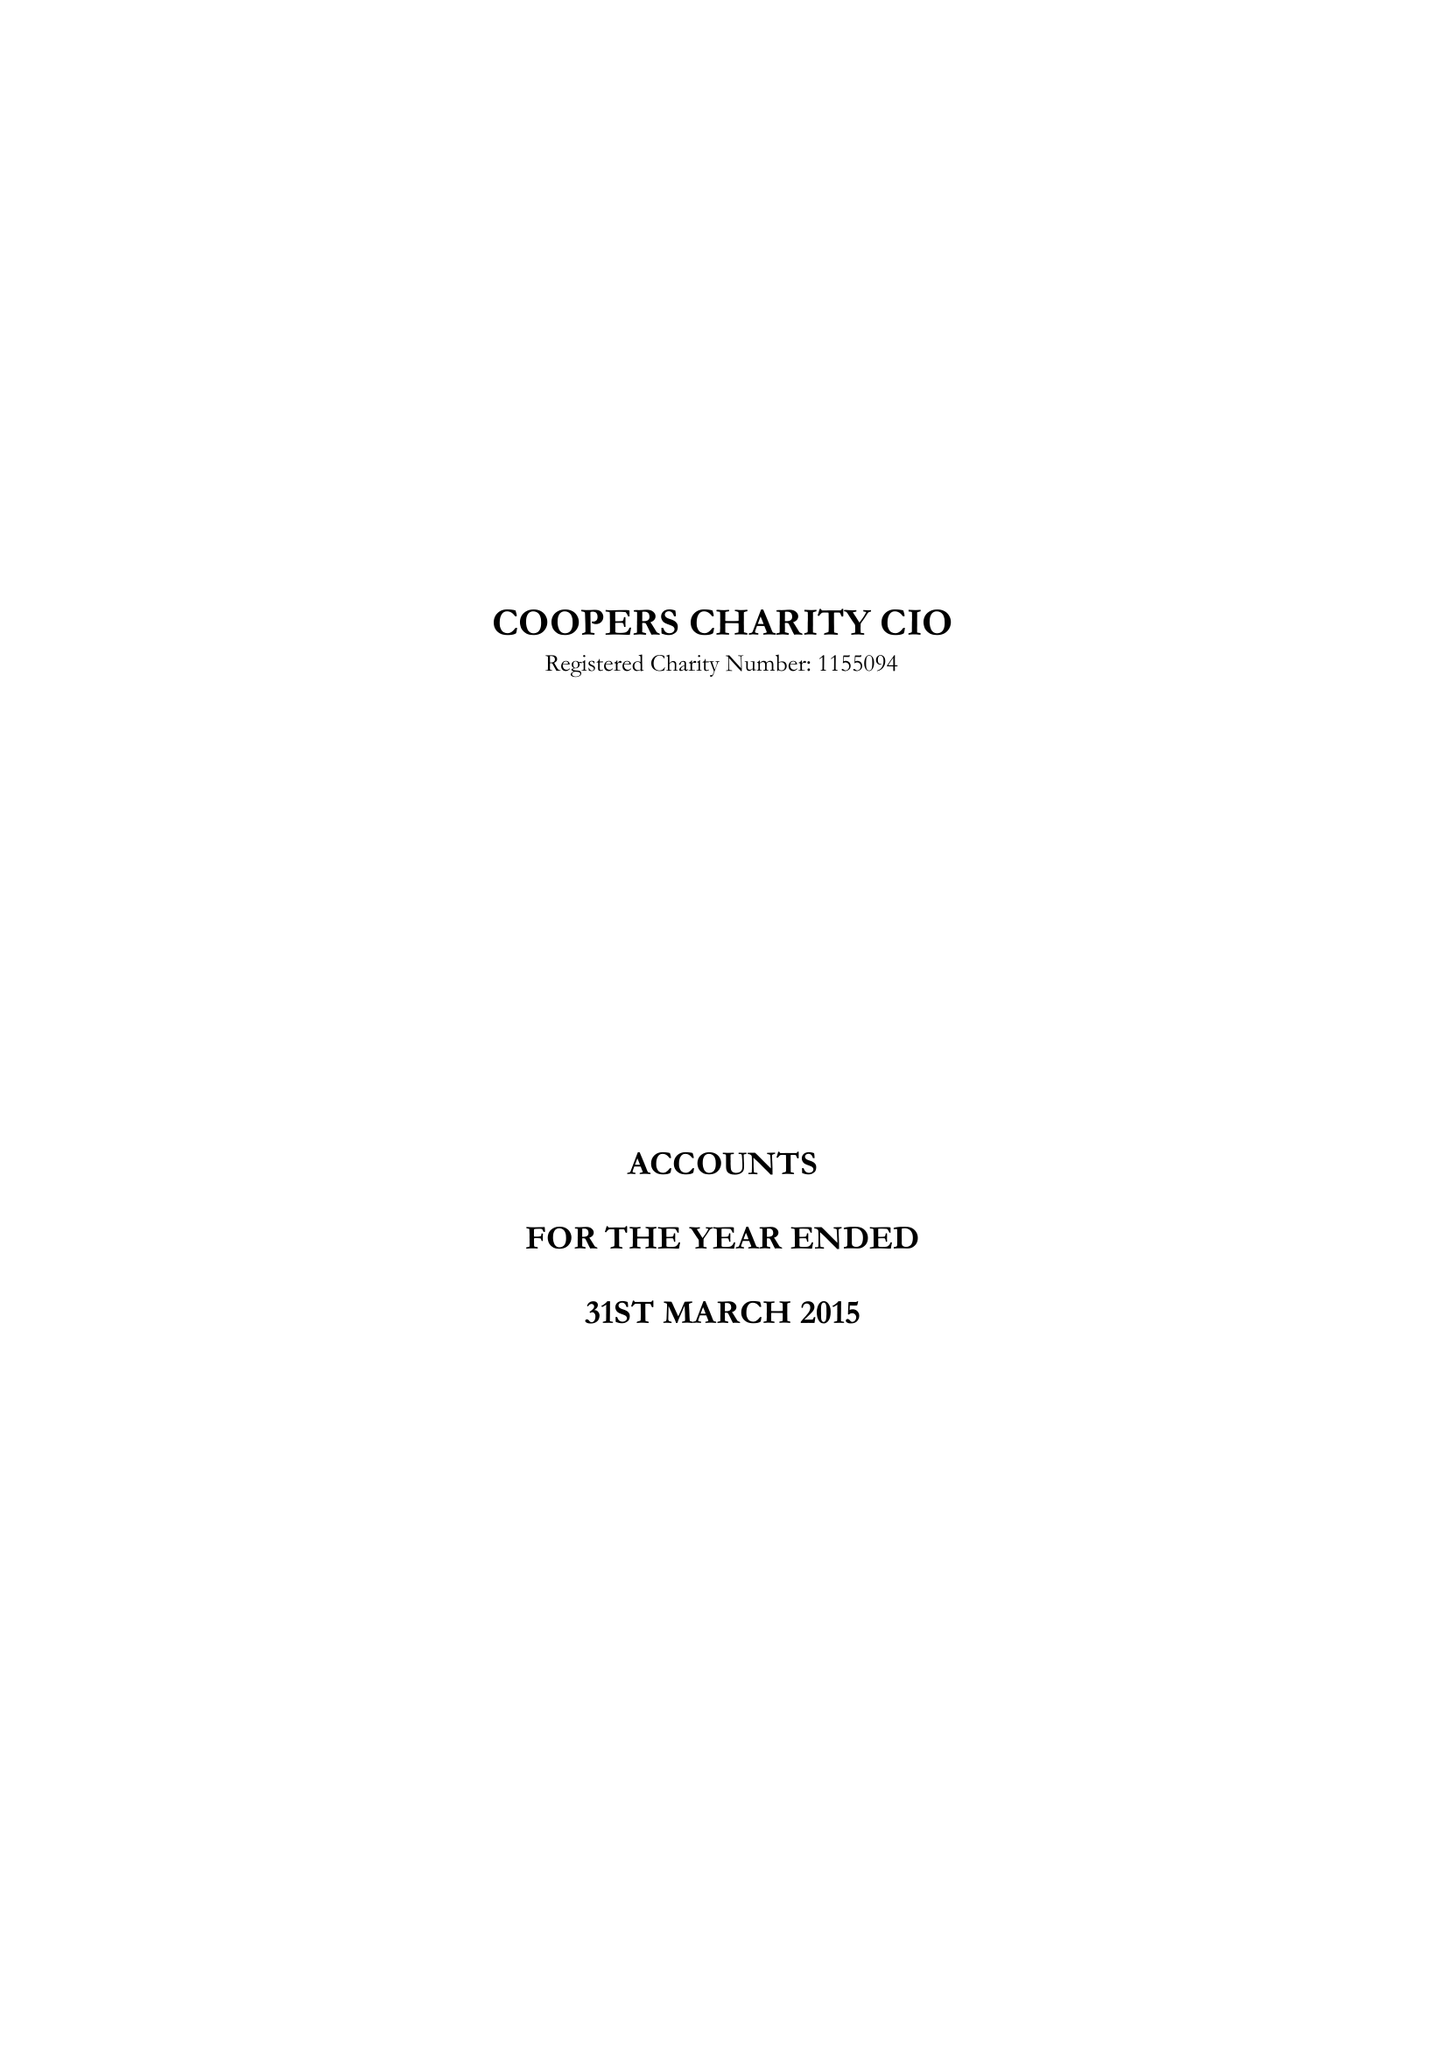What is the value for the report_date?
Answer the question using a single word or phrase. 2015-03-31 